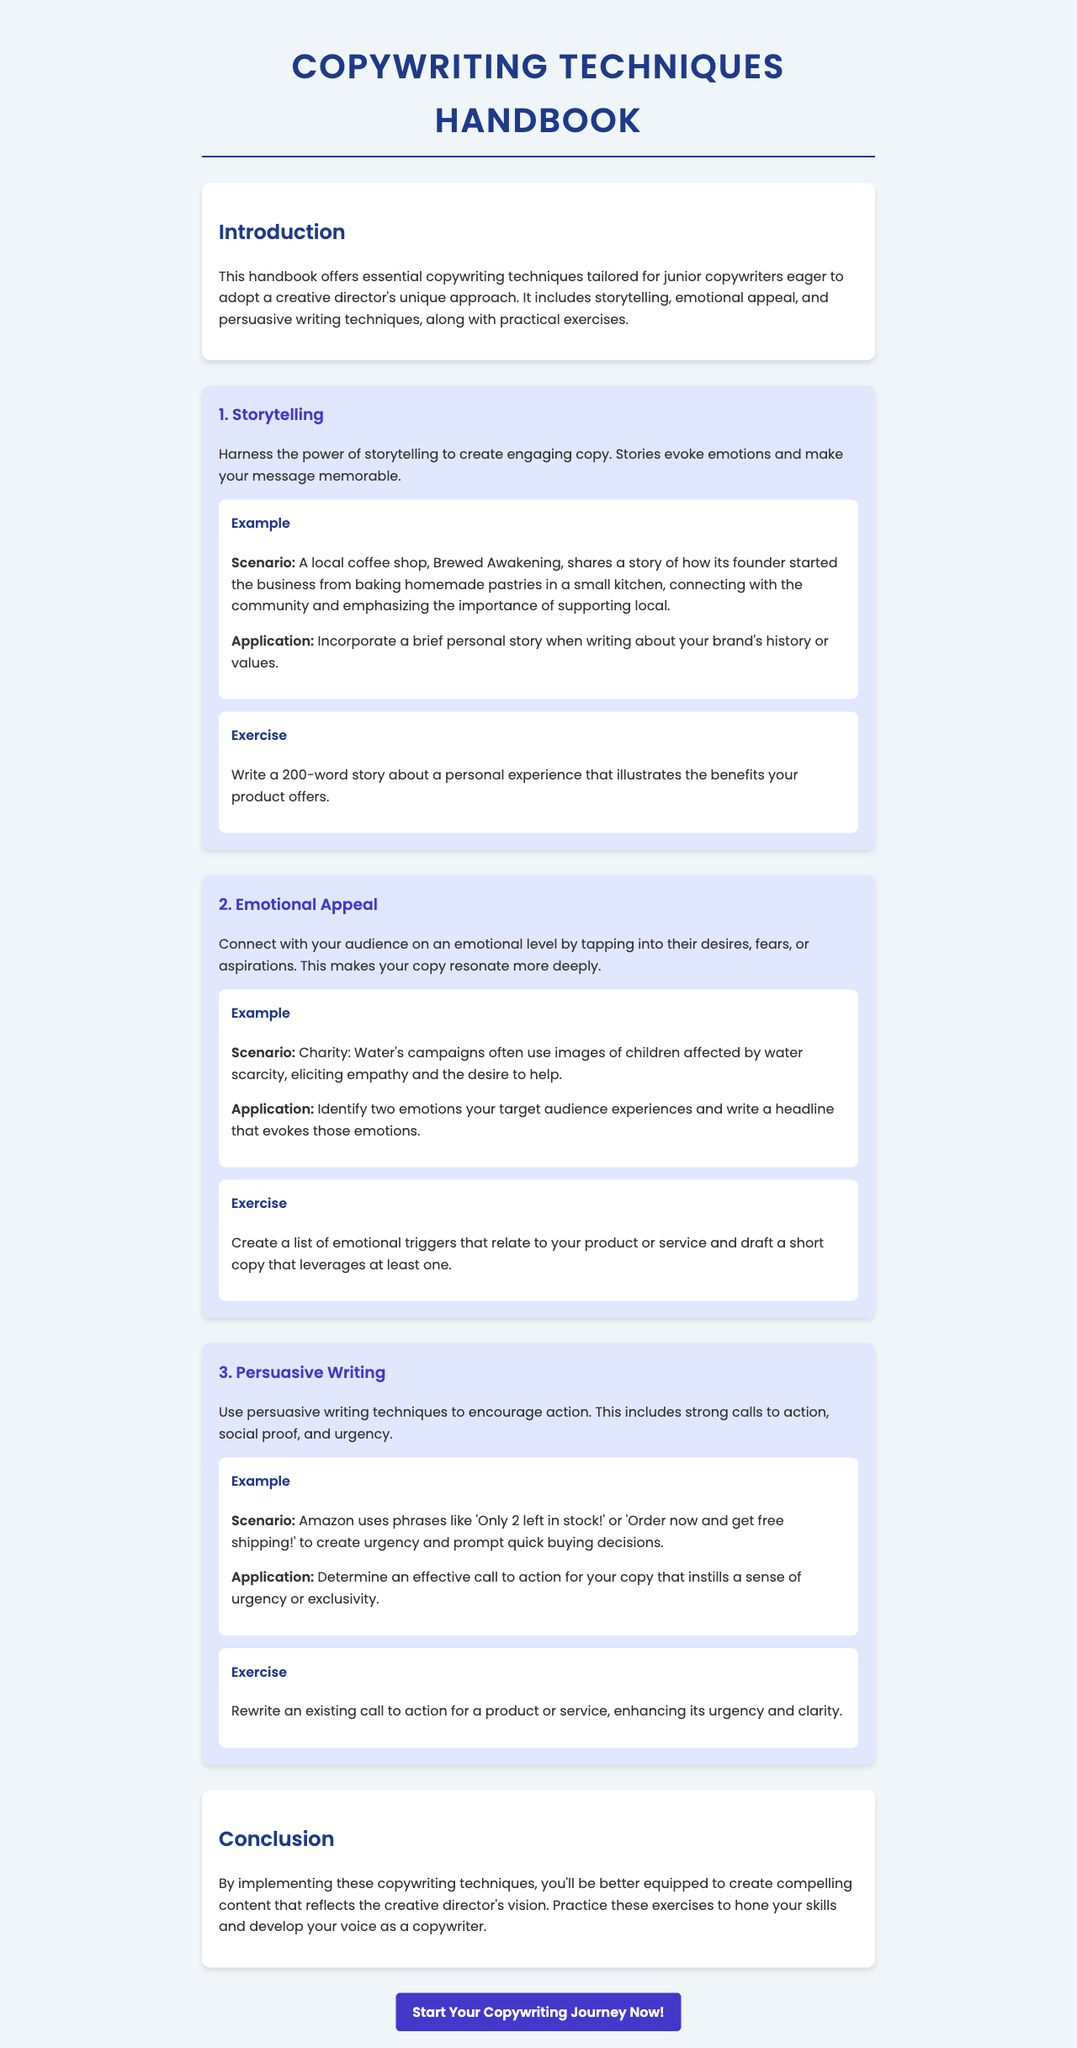What is the title of the document? The title of the document is presented prominently at the top.
Answer: Copywriting Techniques Handbook How many techniques are included in the handbook? The number of techniques is stated in the document's main body.
Answer: Three What is the first technique discussed? The document lists techniques in a specific order, starting with the first one.
Answer: Storytelling What emotional appeal is used in Charity: Water's campaigns? The document describes a scenario that illustrates emotional appeal.
Answer: Empathy What size should the personal story be in the storytelling exercise? The exercise specifies a word count for the story.
Answer: 200 words What color is used for headings in the document? The color style is defined in the document's CSS section for headings.
Answer: Dark blue What is the main purpose of the handbook? The introduction outlines the overall goal of the document.
Answer: Essential copywriting techniques What type of writing encourages action? The document explains a specific writing style that aims to prompt responses.
Answer: Persuasive writing What example does the document provide for urgency? The document includes a specific scenario related to urgency in copy.
Answer: Only 2 left in stock! 